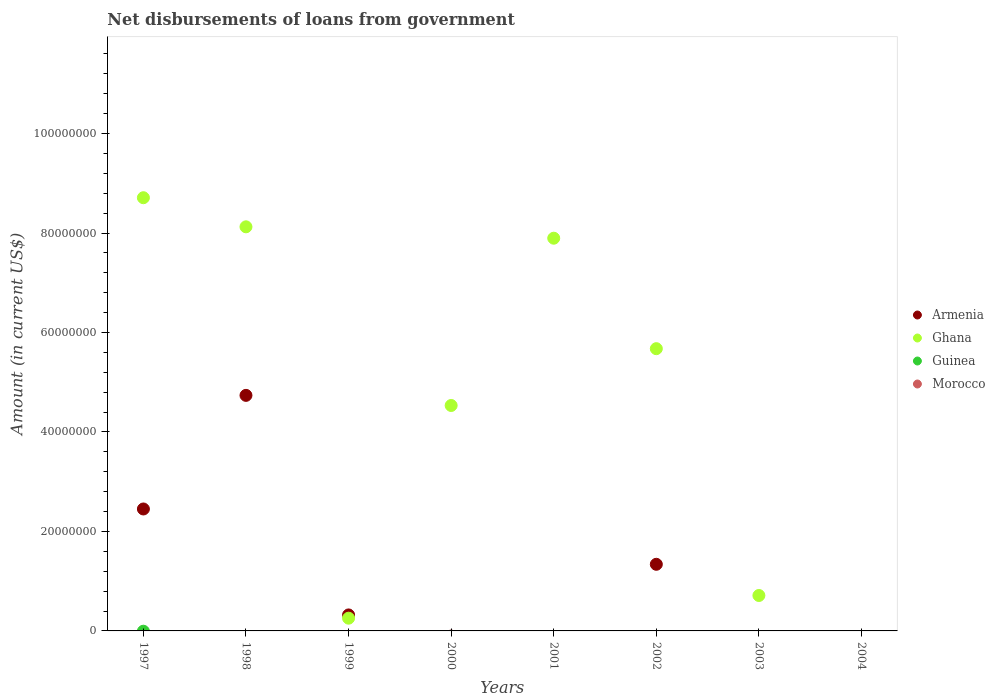Is the number of dotlines equal to the number of legend labels?
Offer a terse response. No. What is the amount of loan disbursed from government in Ghana in 2003?
Make the answer very short. 7.12e+06. Across all years, what is the maximum amount of loan disbursed from government in Armenia?
Offer a very short reply. 4.74e+07. In which year was the amount of loan disbursed from government in Armenia maximum?
Keep it short and to the point. 1998. What is the total amount of loan disbursed from government in Armenia in the graph?
Your answer should be compact. 8.85e+07. What is the difference between the amount of loan disbursed from government in Armenia in 1998 and that in 2002?
Your answer should be compact. 3.40e+07. What is the difference between the amount of loan disbursed from government in Ghana in 2002 and the amount of loan disbursed from government in Morocco in 1997?
Your answer should be very brief. 5.67e+07. What is the average amount of loan disbursed from government in Armenia per year?
Your answer should be very brief. 1.11e+07. In the year 1998, what is the difference between the amount of loan disbursed from government in Armenia and amount of loan disbursed from government in Ghana?
Your answer should be compact. -3.39e+07. In how many years, is the amount of loan disbursed from government in Armenia greater than 4000000 US$?
Your answer should be compact. 3. What is the ratio of the amount of loan disbursed from government in Armenia in 1998 to that in 2002?
Your response must be concise. 3.54. Is the difference between the amount of loan disbursed from government in Armenia in 1997 and 2002 greater than the difference between the amount of loan disbursed from government in Ghana in 1997 and 2002?
Make the answer very short. No. What is the difference between the highest and the second highest amount of loan disbursed from government in Armenia?
Offer a terse response. 2.28e+07. What is the difference between the highest and the lowest amount of loan disbursed from government in Ghana?
Provide a succinct answer. 8.71e+07. In how many years, is the amount of loan disbursed from government in Armenia greater than the average amount of loan disbursed from government in Armenia taken over all years?
Offer a terse response. 3. Is the sum of the amount of loan disbursed from government in Ghana in 1997 and 2001 greater than the maximum amount of loan disbursed from government in Morocco across all years?
Keep it short and to the point. Yes. Is the amount of loan disbursed from government in Armenia strictly less than the amount of loan disbursed from government in Ghana over the years?
Offer a terse response. No. How many years are there in the graph?
Provide a short and direct response. 8. Are the values on the major ticks of Y-axis written in scientific E-notation?
Your response must be concise. No. Does the graph contain any zero values?
Your answer should be compact. Yes. Does the graph contain grids?
Your answer should be compact. No. How many legend labels are there?
Ensure brevity in your answer.  4. What is the title of the graph?
Keep it short and to the point. Net disbursements of loans from government. Does "Tanzania" appear as one of the legend labels in the graph?
Your answer should be compact. No. What is the label or title of the X-axis?
Your response must be concise. Years. What is the label or title of the Y-axis?
Offer a very short reply. Amount (in current US$). What is the Amount (in current US$) in Armenia in 1997?
Provide a succinct answer. 2.45e+07. What is the Amount (in current US$) of Ghana in 1997?
Offer a very short reply. 8.71e+07. What is the Amount (in current US$) in Guinea in 1997?
Offer a very short reply. 0. What is the Amount (in current US$) of Morocco in 1997?
Your response must be concise. 0. What is the Amount (in current US$) of Armenia in 1998?
Offer a terse response. 4.74e+07. What is the Amount (in current US$) in Ghana in 1998?
Your answer should be compact. 8.12e+07. What is the Amount (in current US$) in Guinea in 1998?
Offer a terse response. 0. What is the Amount (in current US$) of Armenia in 1999?
Provide a short and direct response. 3.22e+06. What is the Amount (in current US$) in Ghana in 1999?
Keep it short and to the point. 2.56e+06. What is the Amount (in current US$) in Guinea in 1999?
Make the answer very short. 0. What is the Amount (in current US$) of Ghana in 2000?
Your answer should be compact. 4.53e+07. What is the Amount (in current US$) in Morocco in 2000?
Give a very brief answer. 0. What is the Amount (in current US$) in Ghana in 2001?
Offer a terse response. 7.90e+07. What is the Amount (in current US$) of Guinea in 2001?
Offer a very short reply. 0. What is the Amount (in current US$) of Armenia in 2002?
Your response must be concise. 1.34e+07. What is the Amount (in current US$) in Ghana in 2002?
Provide a short and direct response. 5.67e+07. What is the Amount (in current US$) of Guinea in 2002?
Provide a short and direct response. 0. What is the Amount (in current US$) in Morocco in 2002?
Give a very brief answer. 0. What is the Amount (in current US$) in Armenia in 2003?
Ensure brevity in your answer.  0. What is the Amount (in current US$) of Ghana in 2003?
Your answer should be compact. 7.12e+06. What is the Amount (in current US$) of Guinea in 2003?
Your answer should be very brief. 0. What is the Amount (in current US$) in Ghana in 2004?
Your response must be concise. 0. What is the Amount (in current US$) of Morocco in 2004?
Your answer should be very brief. 0. Across all years, what is the maximum Amount (in current US$) of Armenia?
Provide a succinct answer. 4.74e+07. Across all years, what is the maximum Amount (in current US$) in Ghana?
Your answer should be very brief. 8.71e+07. Across all years, what is the minimum Amount (in current US$) of Armenia?
Provide a short and direct response. 0. What is the total Amount (in current US$) of Armenia in the graph?
Offer a terse response. 8.85e+07. What is the total Amount (in current US$) of Ghana in the graph?
Offer a terse response. 3.59e+08. What is the total Amount (in current US$) of Guinea in the graph?
Your answer should be compact. 0. What is the total Amount (in current US$) of Morocco in the graph?
Make the answer very short. 0. What is the difference between the Amount (in current US$) in Armenia in 1997 and that in 1998?
Your answer should be very brief. -2.28e+07. What is the difference between the Amount (in current US$) of Ghana in 1997 and that in 1998?
Give a very brief answer. 5.85e+06. What is the difference between the Amount (in current US$) of Armenia in 1997 and that in 1999?
Give a very brief answer. 2.13e+07. What is the difference between the Amount (in current US$) of Ghana in 1997 and that in 1999?
Ensure brevity in your answer.  8.45e+07. What is the difference between the Amount (in current US$) in Ghana in 1997 and that in 2000?
Give a very brief answer. 4.18e+07. What is the difference between the Amount (in current US$) in Ghana in 1997 and that in 2001?
Your answer should be compact. 8.14e+06. What is the difference between the Amount (in current US$) in Armenia in 1997 and that in 2002?
Provide a succinct answer. 1.11e+07. What is the difference between the Amount (in current US$) in Ghana in 1997 and that in 2002?
Offer a terse response. 3.04e+07. What is the difference between the Amount (in current US$) of Ghana in 1997 and that in 2003?
Your response must be concise. 8.00e+07. What is the difference between the Amount (in current US$) in Armenia in 1998 and that in 1999?
Make the answer very short. 4.41e+07. What is the difference between the Amount (in current US$) of Ghana in 1998 and that in 1999?
Keep it short and to the point. 7.87e+07. What is the difference between the Amount (in current US$) in Ghana in 1998 and that in 2000?
Your response must be concise. 3.59e+07. What is the difference between the Amount (in current US$) in Ghana in 1998 and that in 2001?
Provide a short and direct response. 2.29e+06. What is the difference between the Amount (in current US$) of Armenia in 1998 and that in 2002?
Provide a short and direct response. 3.40e+07. What is the difference between the Amount (in current US$) in Ghana in 1998 and that in 2002?
Give a very brief answer. 2.45e+07. What is the difference between the Amount (in current US$) in Ghana in 1998 and that in 2003?
Your answer should be very brief. 7.41e+07. What is the difference between the Amount (in current US$) in Ghana in 1999 and that in 2000?
Provide a short and direct response. -4.28e+07. What is the difference between the Amount (in current US$) in Ghana in 1999 and that in 2001?
Make the answer very short. -7.64e+07. What is the difference between the Amount (in current US$) of Armenia in 1999 and that in 2002?
Your answer should be very brief. -1.02e+07. What is the difference between the Amount (in current US$) in Ghana in 1999 and that in 2002?
Provide a succinct answer. -5.42e+07. What is the difference between the Amount (in current US$) in Ghana in 1999 and that in 2003?
Make the answer very short. -4.56e+06. What is the difference between the Amount (in current US$) in Ghana in 2000 and that in 2001?
Your answer should be very brief. -3.36e+07. What is the difference between the Amount (in current US$) in Ghana in 2000 and that in 2002?
Provide a succinct answer. -1.14e+07. What is the difference between the Amount (in current US$) of Ghana in 2000 and that in 2003?
Provide a short and direct response. 3.82e+07. What is the difference between the Amount (in current US$) of Ghana in 2001 and that in 2002?
Ensure brevity in your answer.  2.22e+07. What is the difference between the Amount (in current US$) of Ghana in 2001 and that in 2003?
Keep it short and to the point. 7.18e+07. What is the difference between the Amount (in current US$) of Ghana in 2002 and that in 2003?
Provide a short and direct response. 4.96e+07. What is the difference between the Amount (in current US$) of Armenia in 1997 and the Amount (in current US$) of Ghana in 1998?
Offer a terse response. -5.67e+07. What is the difference between the Amount (in current US$) in Armenia in 1997 and the Amount (in current US$) in Ghana in 1999?
Ensure brevity in your answer.  2.20e+07. What is the difference between the Amount (in current US$) in Armenia in 1997 and the Amount (in current US$) in Ghana in 2000?
Offer a very short reply. -2.08e+07. What is the difference between the Amount (in current US$) of Armenia in 1997 and the Amount (in current US$) of Ghana in 2001?
Offer a terse response. -5.44e+07. What is the difference between the Amount (in current US$) of Armenia in 1997 and the Amount (in current US$) of Ghana in 2002?
Give a very brief answer. -3.22e+07. What is the difference between the Amount (in current US$) of Armenia in 1997 and the Amount (in current US$) of Ghana in 2003?
Offer a very short reply. 1.74e+07. What is the difference between the Amount (in current US$) of Armenia in 1998 and the Amount (in current US$) of Ghana in 1999?
Ensure brevity in your answer.  4.48e+07. What is the difference between the Amount (in current US$) in Armenia in 1998 and the Amount (in current US$) in Ghana in 2000?
Offer a terse response. 2.04e+06. What is the difference between the Amount (in current US$) of Armenia in 1998 and the Amount (in current US$) of Ghana in 2001?
Provide a short and direct response. -3.16e+07. What is the difference between the Amount (in current US$) in Armenia in 1998 and the Amount (in current US$) in Ghana in 2002?
Ensure brevity in your answer.  -9.39e+06. What is the difference between the Amount (in current US$) in Armenia in 1998 and the Amount (in current US$) in Ghana in 2003?
Ensure brevity in your answer.  4.02e+07. What is the difference between the Amount (in current US$) of Armenia in 1999 and the Amount (in current US$) of Ghana in 2000?
Your answer should be very brief. -4.21e+07. What is the difference between the Amount (in current US$) of Armenia in 1999 and the Amount (in current US$) of Ghana in 2001?
Your answer should be very brief. -7.57e+07. What is the difference between the Amount (in current US$) in Armenia in 1999 and the Amount (in current US$) in Ghana in 2002?
Provide a succinct answer. -5.35e+07. What is the difference between the Amount (in current US$) in Armenia in 1999 and the Amount (in current US$) in Ghana in 2003?
Your response must be concise. -3.91e+06. What is the difference between the Amount (in current US$) in Armenia in 2002 and the Amount (in current US$) in Ghana in 2003?
Offer a terse response. 6.27e+06. What is the average Amount (in current US$) of Armenia per year?
Keep it short and to the point. 1.11e+07. What is the average Amount (in current US$) in Ghana per year?
Provide a succinct answer. 4.49e+07. What is the average Amount (in current US$) of Morocco per year?
Offer a terse response. 0. In the year 1997, what is the difference between the Amount (in current US$) in Armenia and Amount (in current US$) in Ghana?
Your answer should be very brief. -6.26e+07. In the year 1998, what is the difference between the Amount (in current US$) in Armenia and Amount (in current US$) in Ghana?
Make the answer very short. -3.39e+07. In the year 1999, what is the difference between the Amount (in current US$) in Armenia and Amount (in current US$) in Ghana?
Your answer should be compact. 6.54e+05. In the year 2002, what is the difference between the Amount (in current US$) of Armenia and Amount (in current US$) of Ghana?
Keep it short and to the point. -4.34e+07. What is the ratio of the Amount (in current US$) in Armenia in 1997 to that in 1998?
Give a very brief answer. 0.52. What is the ratio of the Amount (in current US$) in Ghana in 1997 to that in 1998?
Keep it short and to the point. 1.07. What is the ratio of the Amount (in current US$) in Armenia in 1997 to that in 1999?
Make the answer very short. 7.63. What is the ratio of the Amount (in current US$) of Ghana in 1997 to that in 1999?
Your answer should be compact. 34.01. What is the ratio of the Amount (in current US$) of Ghana in 1997 to that in 2000?
Your answer should be compact. 1.92. What is the ratio of the Amount (in current US$) in Ghana in 1997 to that in 2001?
Provide a succinct answer. 1.1. What is the ratio of the Amount (in current US$) of Armenia in 1997 to that in 2002?
Offer a terse response. 1.83. What is the ratio of the Amount (in current US$) of Ghana in 1997 to that in 2002?
Your answer should be compact. 1.53. What is the ratio of the Amount (in current US$) of Ghana in 1997 to that in 2003?
Offer a very short reply. 12.23. What is the ratio of the Amount (in current US$) in Armenia in 1998 to that in 1999?
Give a very brief answer. 14.73. What is the ratio of the Amount (in current US$) in Ghana in 1998 to that in 1999?
Make the answer very short. 31.73. What is the ratio of the Amount (in current US$) in Ghana in 1998 to that in 2000?
Offer a terse response. 1.79. What is the ratio of the Amount (in current US$) in Armenia in 1998 to that in 2002?
Keep it short and to the point. 3.54. What is the ratio of the Amount (in current US$) of Ghana in 1998 to that in 2002?
Give a very brief answer. 1.43. What is the ratio of the Amount (in current US$) of Ghana in 1998 to that in 2003?
Provide a succinct answer. 11.41. What is the ratio of the Amount (in current US$) of Ghana in 1999 to that in 2000?
Your answer should be very brief. 0.06. What is the ratio of the Amount (in current US$) in Ghana in 1999 to that in 2001?
Offer a terse response. 0.03. What is the ratio of the Amount (in current US$) in Armenia in 1999 to that in 2002?
Give a very brief answer. 0.24. What is the ratio of the Amount (in current US$) of Ghana in 1999 to that in 2002?
Make the answer very short. 0.05. What is the ratio of the Amount (in current US$) in Ghana in 1999 to that in 2003?
Offer a very short reply. 0.36. What is the ratio of the Amount (in current US$) of Ghana in 2000 to that in 2001?
Give a very brief answer. 0.57. What is the ratio of the Amount (in current US$) of Ghana in 2000 to that in 2002?
Ensure brevity in your answer.  0.8. What is the ratio of the Amount (in current US$) of Ghana in 2000 to that in 2003?
Your response must be concise. 6.36. What is the ratio of the Amount (in current US$) in Ghana in 2001 to that in 2002?
Provide a short and direct response. 1.39. What is the ratio of the Amount (in current US$) in Ghana in 2001 to that in 2003?
Provide a short and direct response. 11.08. What is the ratio of the Amount (in current US$) in Ghana in 2002 to that in 2003?
Your answer should be very brief. 7.97. What is the difference between the highest and the second highest Amount (in current US$) of Armenia?
Keep it short and to the point. 2.28e+07. What is the difference between the highest and the second highest Amount (in current US$) in Ghana?
Provide a succinct answer. 5.85e+06. What is the difference between the highest and the lowest Amount (in current US$) of Armenia?
Give a very brief answer. 4.74e+07. What is the difference between the highest and the lowest Amount (in current US$) of Ghana?
Keep it short and to the point. 8.71e+07. 